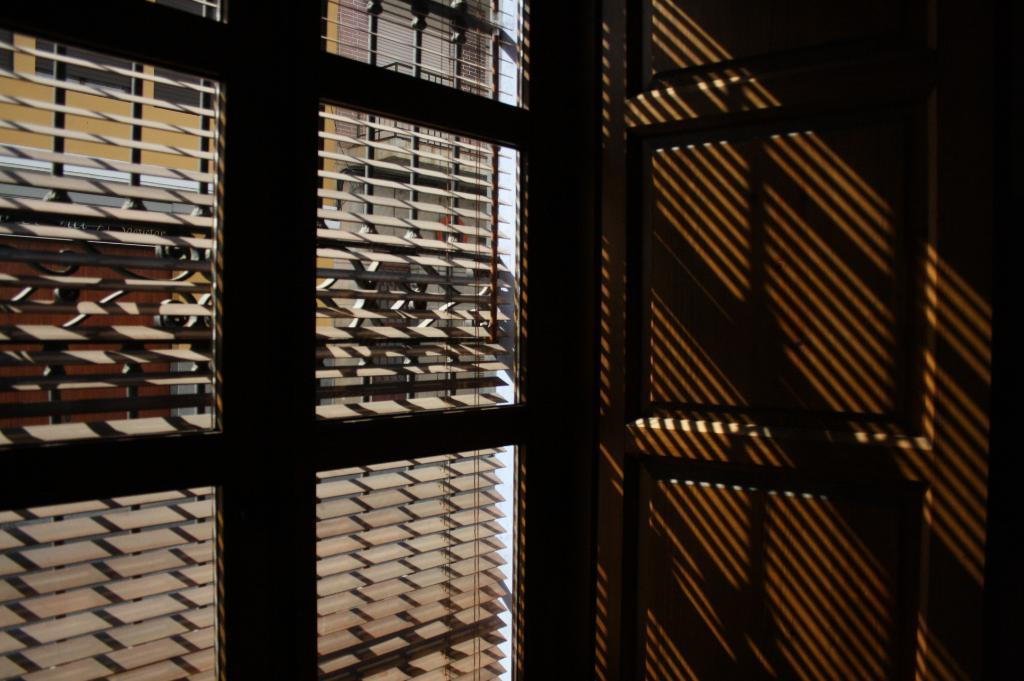What type of opening can be seen in the image? There is a window in the image. What other type of opening is present in the image? There is a door in the image. What can be seen through the window? There is a building visible through the window, as well as other objects. What color is the blood on the foot of the crook in the image? There is no blood, foot, or crook present in the image. 